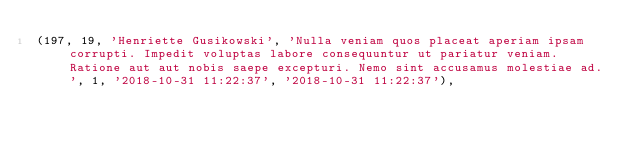<code> <loc_0><loc_0><loc_500><loc_500><_SQL_>(197, 19, 'Henriette Gusikowski', 'Nulla veniam quos placeat aperiam ipsam corrupti. Impedit voluptas labore consequuntur ut pariatur veniam. Ratione aut aut nobis saepe excepturi. Nemo sint accusamus molestiae ad.', 1, '2018-10-31 11:22:37', '2018-10-31 11:22:37'),</code> 